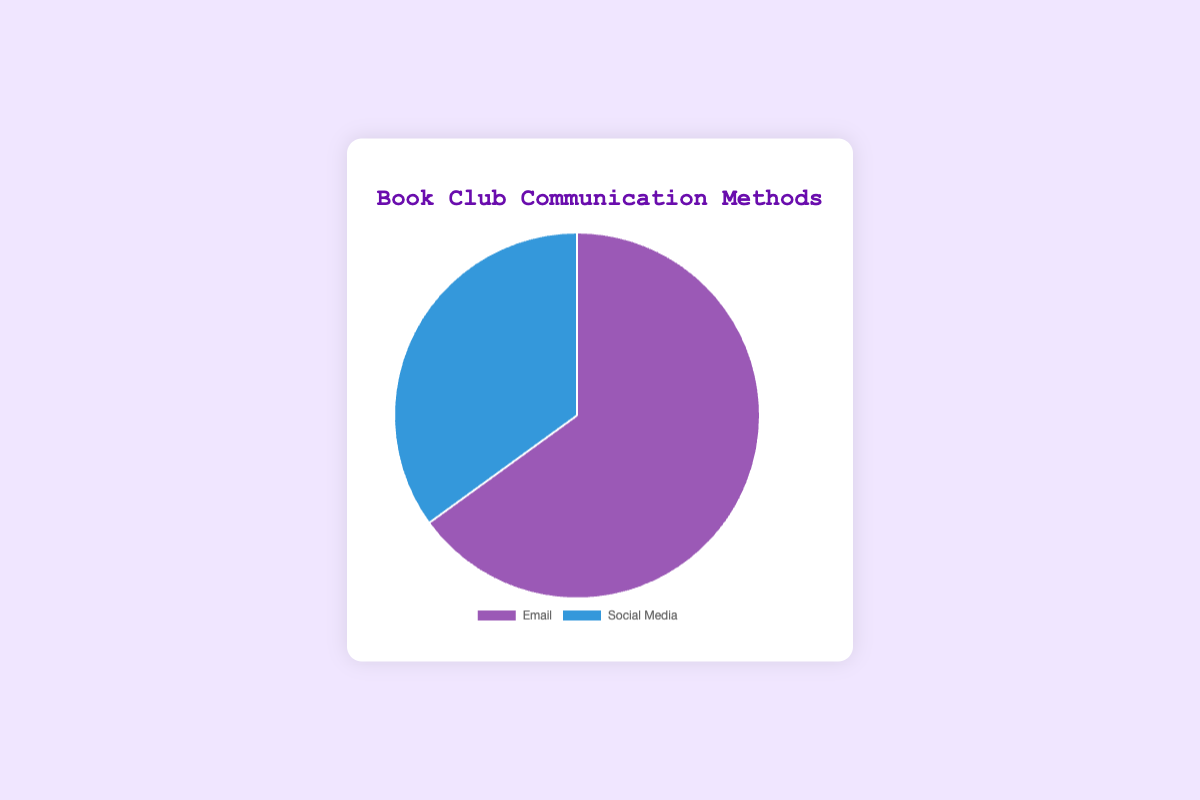What's the primary method of communication for the book club? The pie chart shows that the majority of the book club members use email as their main communication method. The percentage of email users is higher than social media users.
Answer: Email Which communication method is less common for the book club? The smaller portion of the pie chart represents the less common communication method. According to the chart, fewer members use social media compared to email.
Answer: Social Media By how much percent do email communications exceed social media communications? The percentage for email communications is 65%, and for social media, it’s 35%. The difference is calculated by subtracting the smaller percentage from the larger one (65% - 35% = 30%).
Answer: 30% What is the total percentage of book club members using either email or social media for communication? The chart only shows two communication methods, and their percentages are 65% and 35%. Adding these two percentages gives the total (65% + 35% = 100%).
Answer: 100% What fraction of the pie chart is represented by email communication? The email communication makes up 65% of the pie chart. Since percentages can be converted into fractions, we have 65/100, which simplifies to 13/20.
Answer: 13/20 Given that the pie chart segments are colored differently, what color represents the email communication method? From the chart's color coding, the email segment is represented by a purple color, while social media is represented by a blue color.
Answer: Purple If you were to double the percentage of social media users, what would be the new percentage? The current percentage for social media is 35%. Doubling this percentage means multiplying by 2 (35% * 2 = 70%).
Answer: 70% What percentage of the pie chart is not occupied by email communication? The percentage not occupied by email communication can be found by subtracting the email percentage from the total percentage (100% - 65% = 35%).
Answer: 35% How does the visual size of the email segment compare to the social media segment? Visually, the email segment occupies a larger portion of the pie chart compared to the social media segment. This reflects the higher percentage of email users.
Answer: Larger 